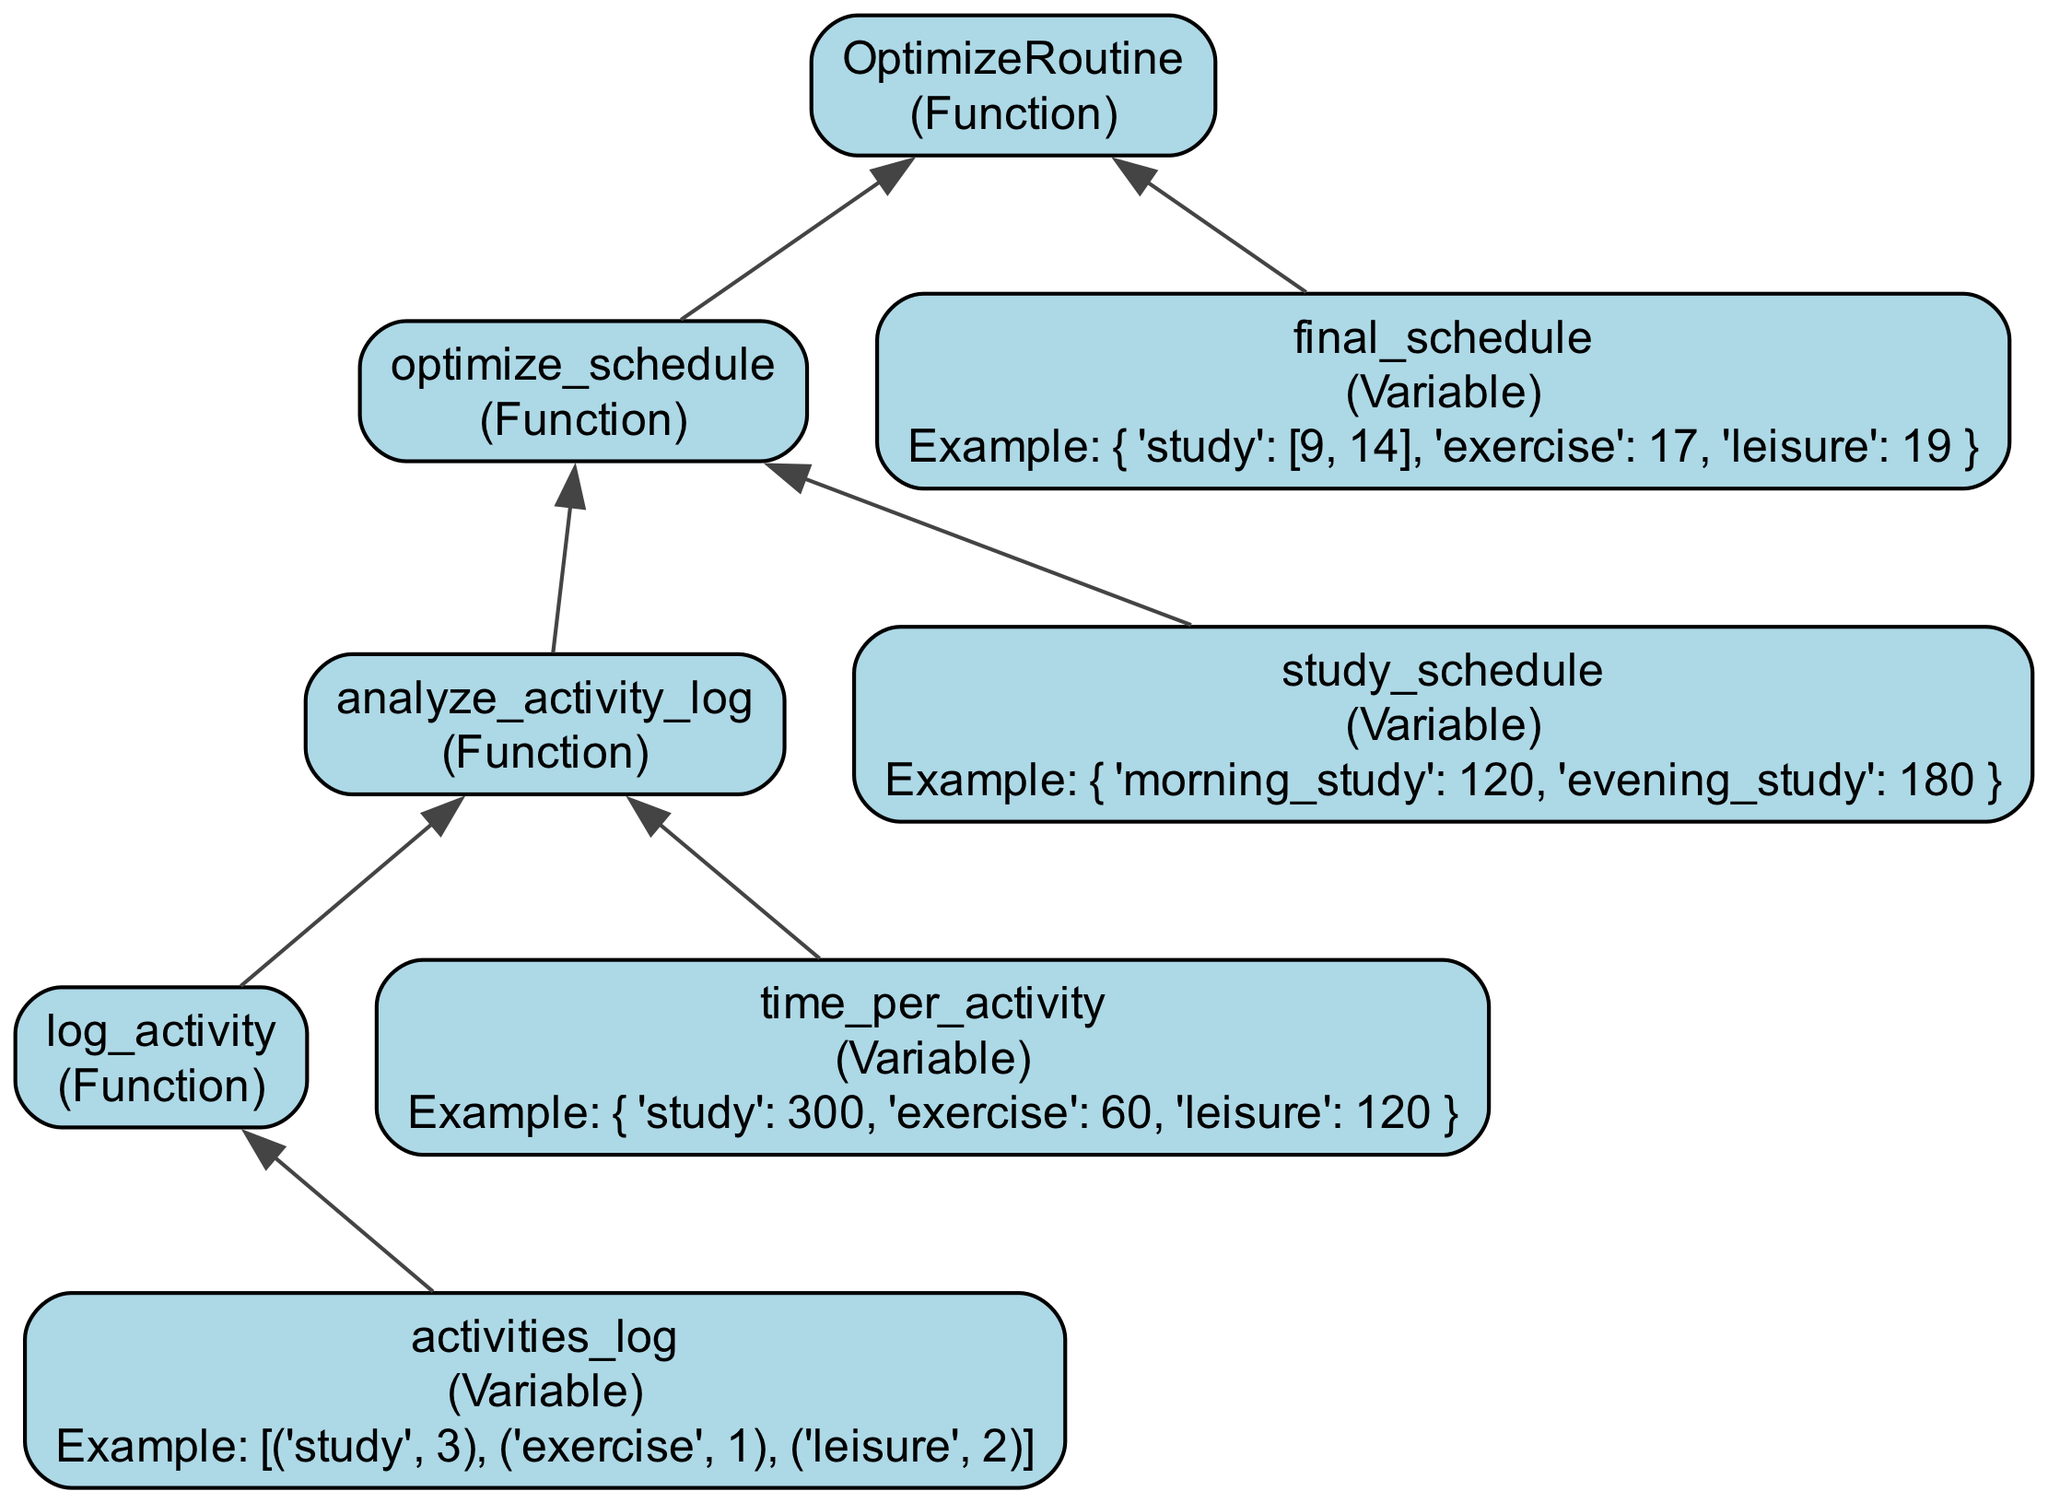What is the main function of the flowchart? The main function in the flowchart is "OptimizeRoutine," which is designed to optimize the daily routine.
Answer: OptimizeRoutine How many functions are represented in the diagram? There are four functions represented: OptimizeRoutine, log_activity, analyze_activity_log, and optimize_schedule.
Answer: Four What type of variable is "time_per_activity"? The variable "time_per_activity" is a dictionary used to hold the time spent on different activities.
Answer: Dictionary Which function takes the output from "analyze_activity_log"? The function that takes the output from "analyze_activity_log" is "optimize_schedule."
Answer: optimize_schedule What does "activities_log" store? The variable "activities_log" stores a list of activity logs throughout the day.
Answer: A list of activity logs What is the final output of the flowchart after optimization? The final output of the flowchart is represented by the variable "final_schedule," which contains the optimized schedule for the day.
Answer: final_schedule Which two variables are connected to the "optimize_schedule" function? The two variables connected to "optimize_schedule" are "time_per_activity" and "study_schedule."
Answer: time_per_activity and study_schedule What is the relationship between "log_activity" and "analyze_activity_log"? The relationship is that "log_activity" connects to "analyze_activity_log," indicating that logged activities are analyzed.
Answer: Log and analyze How is "final_schedule" related to "OptimizeRoutine"? "final_schedule" is an output of the "OptimizeRoutine," indicating it is the result of the routine optimization process.
Answer: Output of OptimizeRoutine 